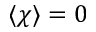<formula> <loc_0><loc_0><loc_500><loc_500>\langle \chi \rangle = 0</formula> 